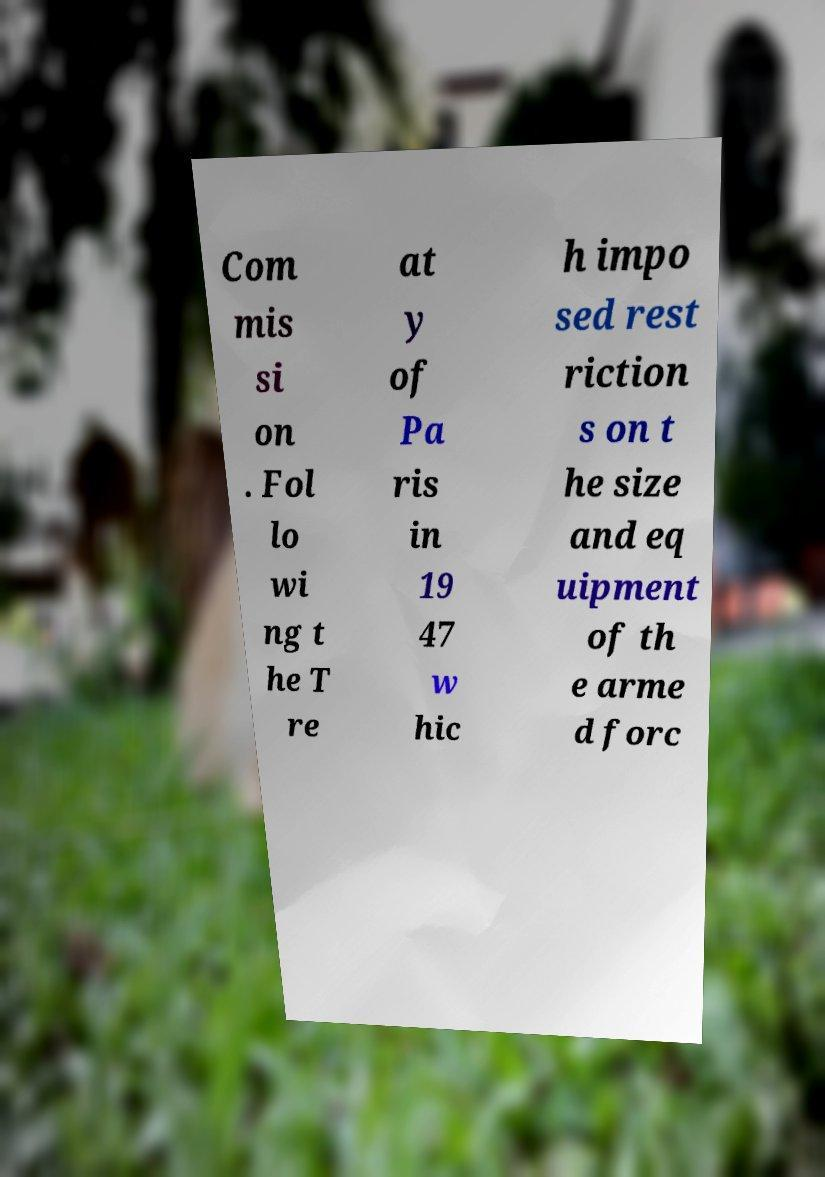Could you extract and type out the text from this image? Com mis si on . Fol lo wi ng t he T re at y of Pa ris in 19 47 w hic h impo sed rest riction s on t he size and eq uipment of th e arme d forc 